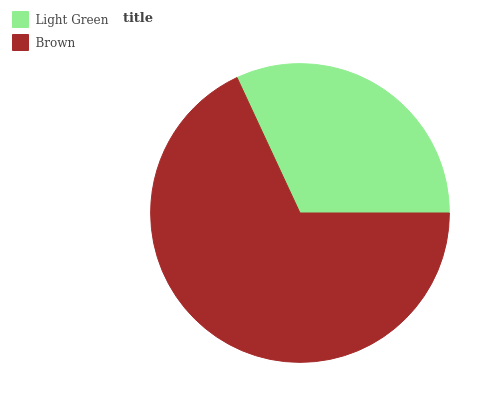Is Light Green the minimum?
Answer yes or no. Yes. Is Brown the maximum?
Answer yes or no. Yes. Is Brown the minimum?
Answer yes or no. No. Is Brown greater than Light Green?
Answer yes or no. Yes. Is Light Green less than Brown?
Answer yes or no. Yes. Is Light Green greater than Brown?
Answer yes or no. No. Is Brown less than Light Green?
Answer yes or no. No. Is Brown the high median?
Answer yes or no. Yes. Is Light Green the low median?
Answer yes or no. Yes. Is Light Green the high median?
Answer yes or no. No. Is Brown the low median?
Answer yes or no. No. 